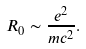Convert formula to latex. <formula><loc_0><loc_0><loc_500><loc_500>R _ { 0 } \sim \frac { e ^ { 2 } } { m c ^ { 2 } } .</formula> 